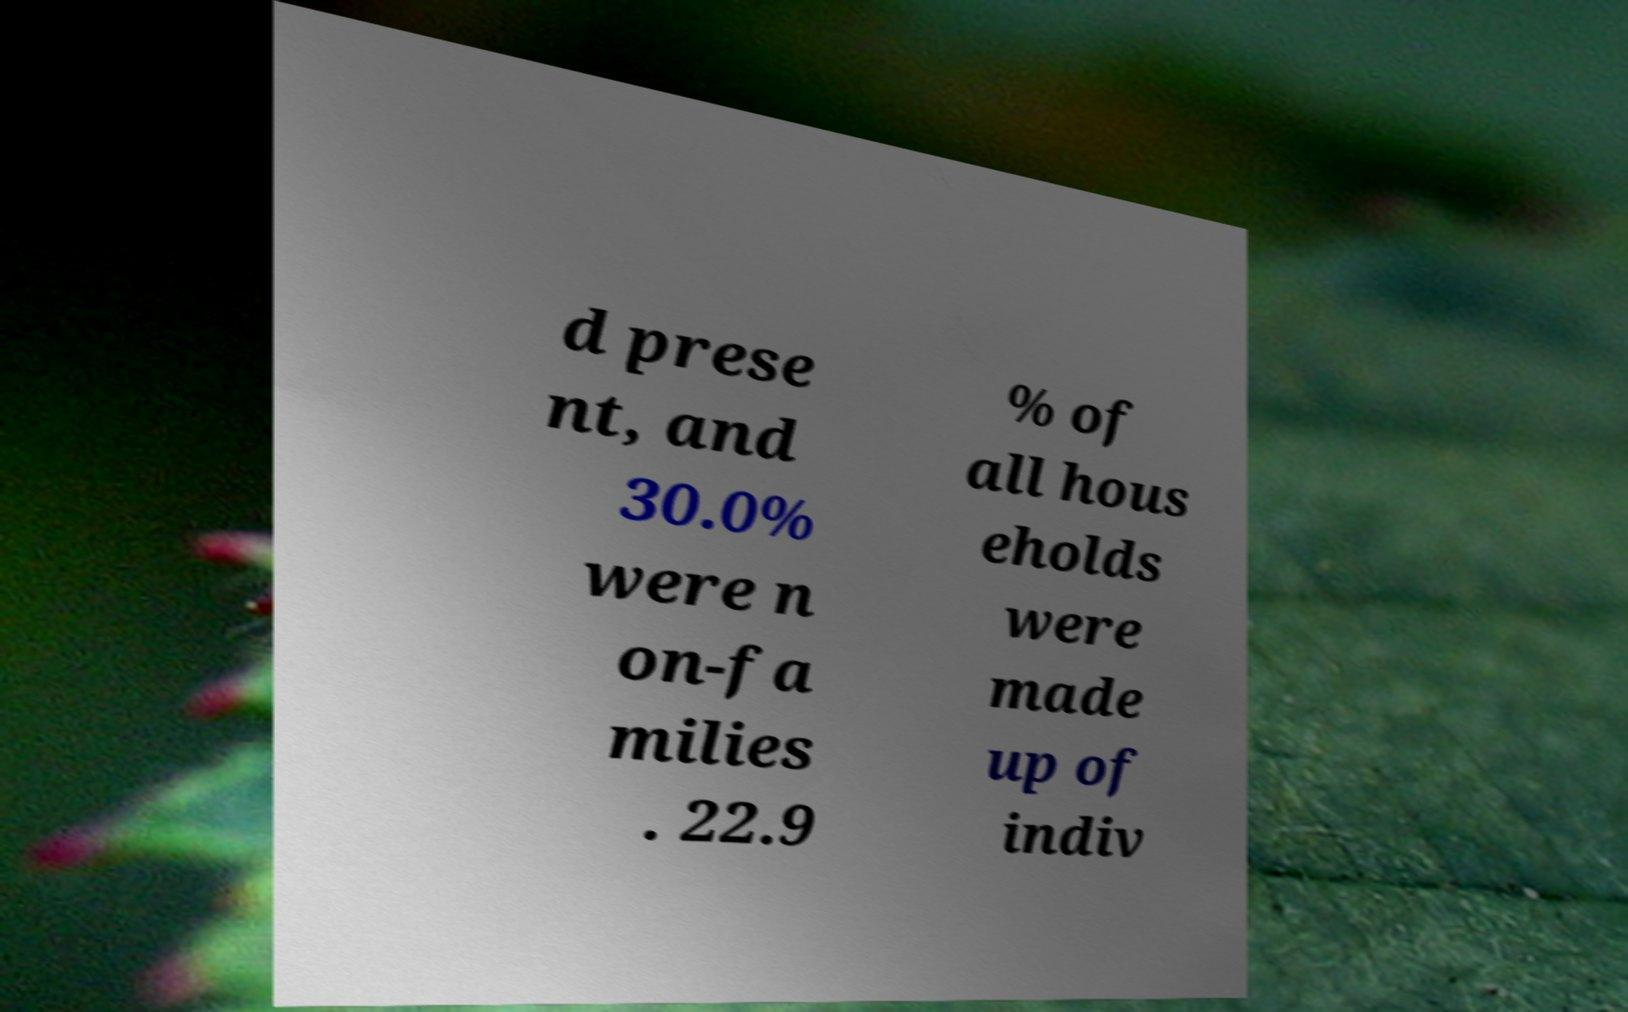What messages or text are displayed in this image? I need them in a readable, typed format. d prese nt, and 30.0% were n on-fa milies . 22.9 % of all hous eholds were made up of indiv 